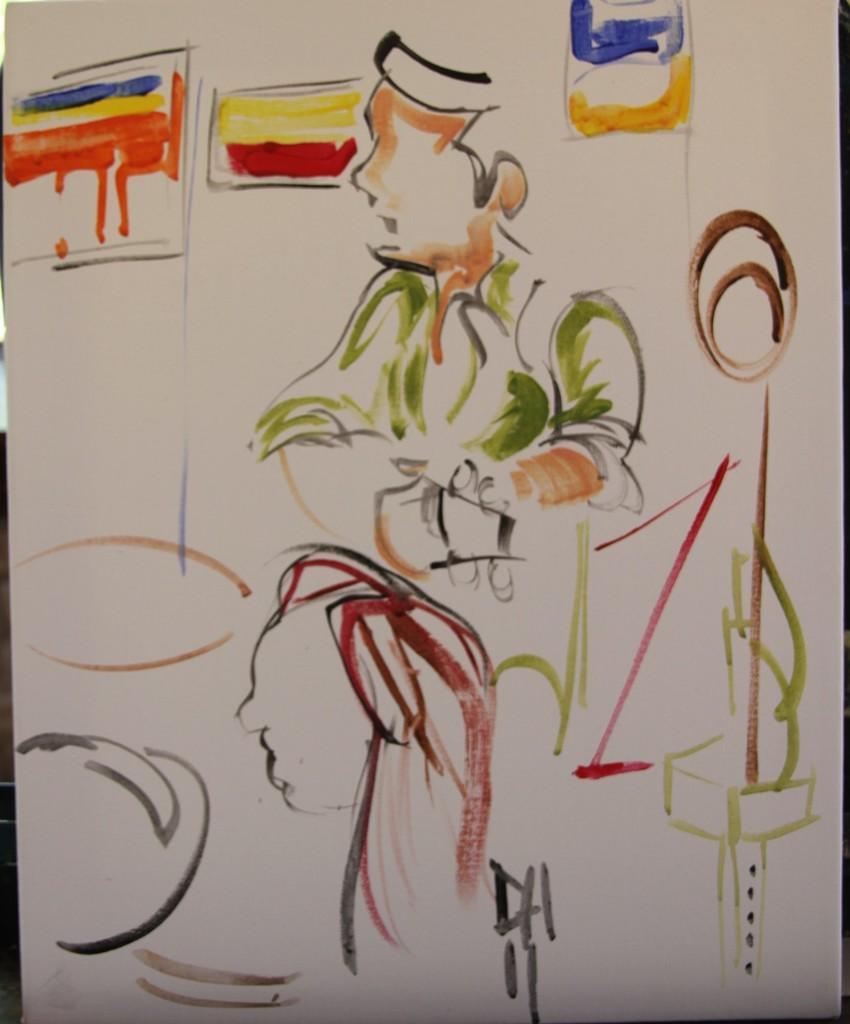Could you give a brief overview of what you see in this image? This is a painted image. 